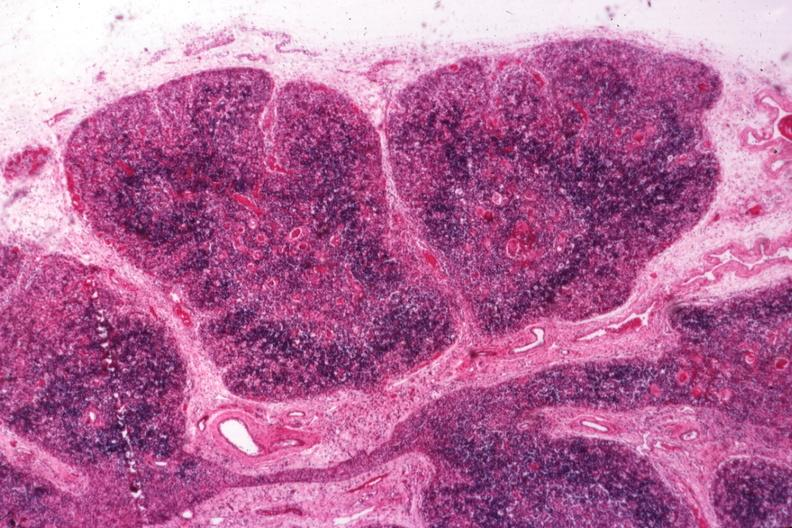s hematologic present?
Answer the question using a single word or phrase. Yes 